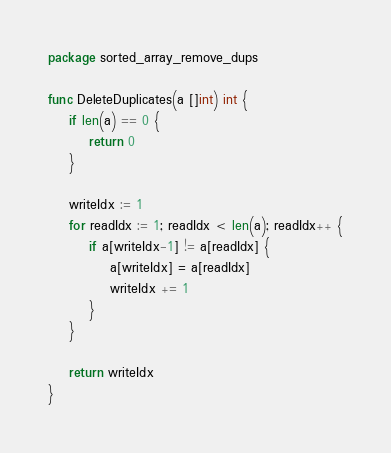<code> <loc_0><loc_0><loc_500><loc_500><_Go_>package sorted_array_remove_dups

func DeleteDuplicates(a []int) int {
	if len(a) == 0 {
		return 0
	}

	writeIdx := 1
	for readIdx := 1; readIdx < len(a); readIdx++ {
		if a[writeIdx-1] != a[readIdx] {
			a[writeIdx] = a[readIdx]
			writeIdx += 1
		}
	}

	return writeIdx
}
</code> 